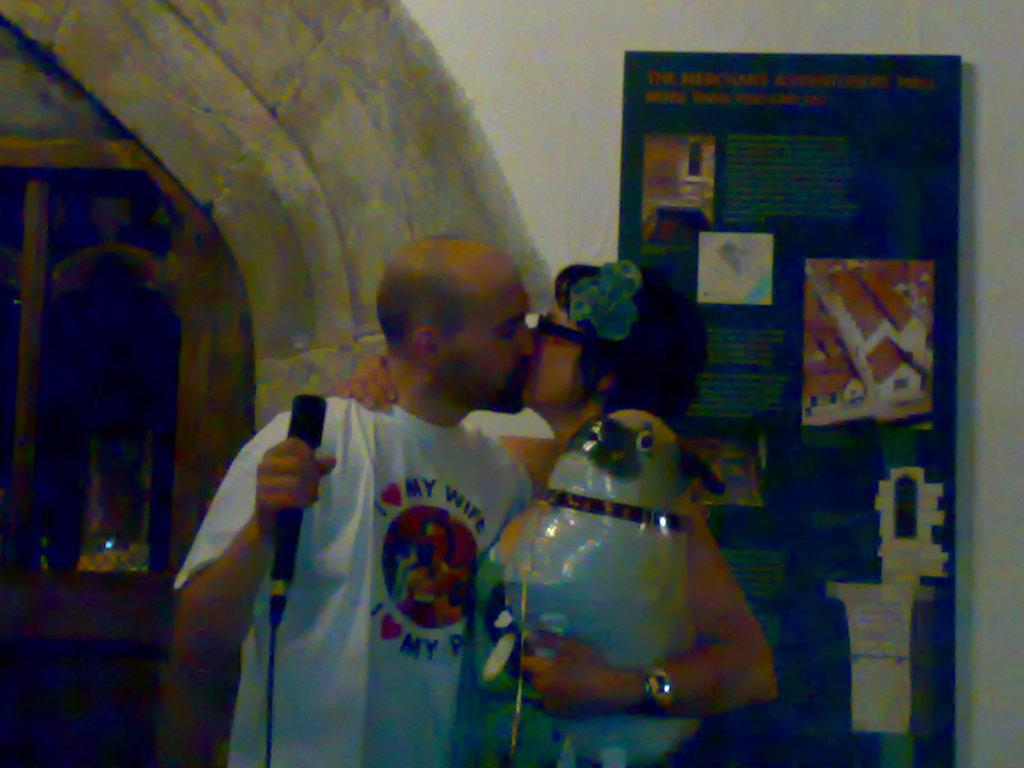What is the man holding in the image? The man is holding a microphone in the image. What is the woman holding in the image? The woman is holding an object in the image. What are the man and woman doing in the image? The man and woman are kissing in the image. What can be seen in the background of the image? There is a window and a board attached to the wall in the background of the image. What is the purpose of the sugar in the image? There is no sugar present in the image. Can you see any stars in the image? There are no stars visible in the image. 